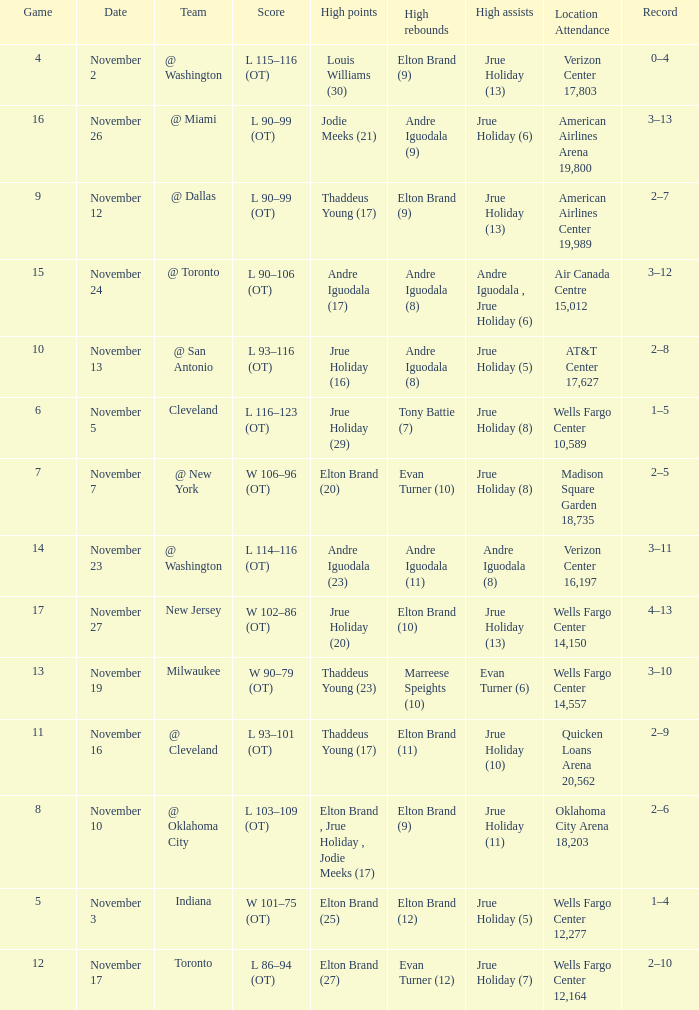What is the score for the game with the record of 3–12? L 90–106 (OT). 